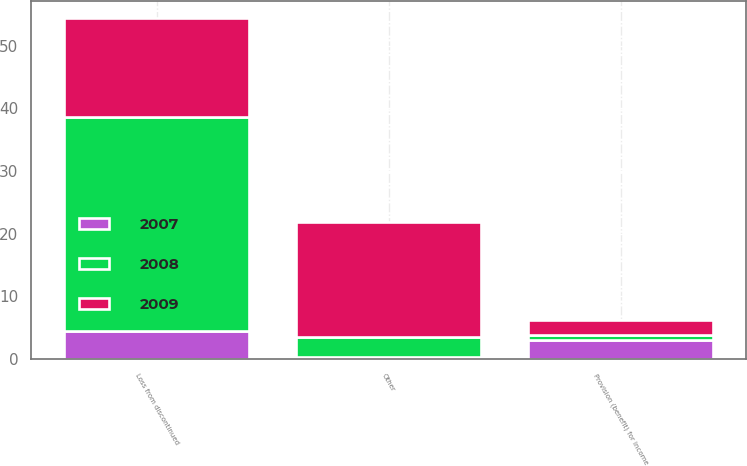Convert chart to OTSL. <chart><loc_0><loc_0><loc_500><loc_500><stacked_bar_chart><ecel><fcel>Other<fcel>Loss from discontinued<fcel>Provision (benefit) for income<nl><fcel>2007<fcel>0.3<fcel>4.5<fcel>3<nl><fcel>2008<fcel>3.2<fcel>34.1<fcel>0.8<nl><fcel>2009<fcel>18.3<fcel>15.8<fcel>2.5<nl></chart> 